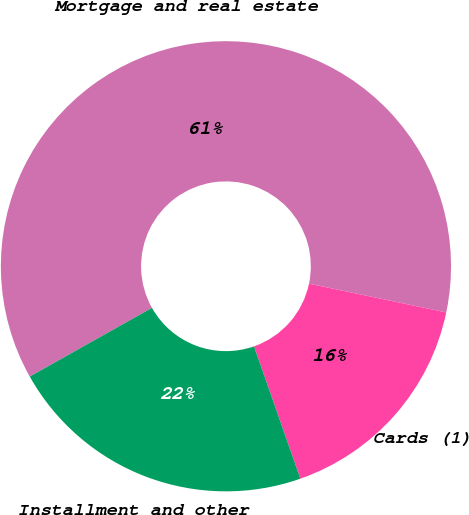<chart> <loc_0><loc_0><loc_500><loc_500><pie_chart><fcel>Mortgage and real estate<fcel>Cards (1)<fcel>Installment and other<nl><fcel>61.44%<fcel>16.35%<fcel>22.21%<nl></chart> 